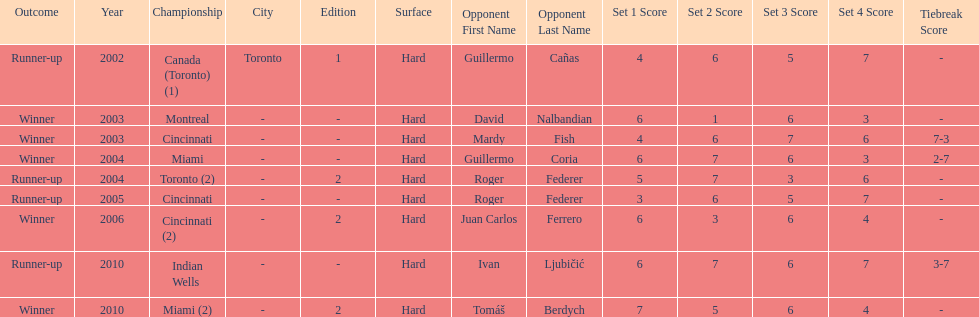How many total wins has he had? 5. Parse the full table. {'header': ['Outcome', 'Year', 'Championship', 'City', 'Edition', 'Surface', 'Opponent First Name', 'Opponent Last Name', 'Set 1 Score', 'Set 2 Score', 'Set 3 Score', 'Set 4 Score', 'Tiebreak Score'], 'rows': [['Runner-up', '2002', 'Canada (Toronto) (1)', 'Toronto', '1', 'Hard', 'Guillermo', 'Cañas', '4', '6', '5', '7', '-'], ['Winner', '2003', 'Montreal', '-', '-', 'Hard', 'David', 'Nalbandian', '6', '1', '6', '3', '-'], ['Winner', '2003', 'Cincinnati', '-', '-', 'Hard', 'Mardy', 'Fish', '4', '6', '7', '6', '7-3'], ['Winner', '2004', 'Miami', '-', '-', 'Hard', 'Guillermo', 'Coria', '6', '7', '6', '3', '2-7'], ['Runner-up', '2004', 'Toronto (2)', '-', '2', 'Hard', 'Roger', 'Federer', '5', '7', '3', '6', '-'], ['Runner-up', '2005', 'Cincinnati', '-', '-', 'Hard', 'Roger', 'Federer', '3', '6', '5', '7', '-'], ['Winner', '2006', 'Cincinnati (2)', '-', '2', 'Hard', 'Juan Carlos', 'Ferrero', '6', '3', '6', '4', '-'], ['Runner-up', '2010', 'Indian Wells', '-', '-', 'Hard', 'Ivan', 'Ljubičić', '6', '7', '6', '7', '3-7'], ['Winner', '2010', 'Miami (2)', '-', '2', 'Hard', 'Tomáš', 'Berdych', '7', '5', '6', '4', '-']]} 